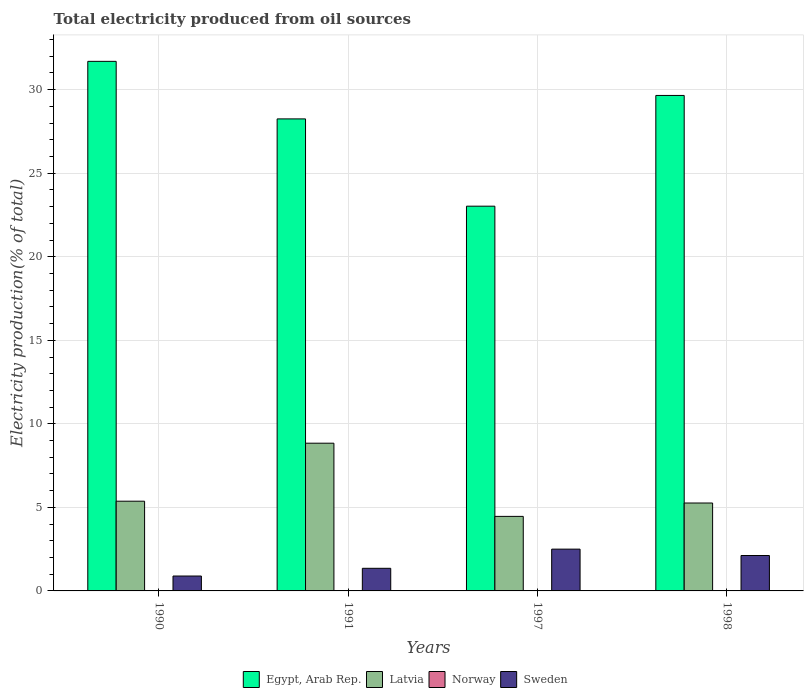How many groups of bars are there?
Keep it short and to the point. 4. How many bars are there on the 2nd tick from the left?
Your answer should be very brief. 4. What is the label of the 4th group of bars from the left?
Your response must be concise. 1998. What is the total electricity produced in Latvia in 1991?
Your answer should be compact. 8.84. Across all years, what is the maximum total electricity produced in Sweden?
Your answer should be very brief. 2.5. Across all years, what is the minimum total electricity produced in Norway?
Your answer should be compact. 0. In which year was the total electricity produced in Sweden maximum?
Offer a very short reply. 1997. In which year was the total electricity produced in Norway minimum?
Offer a very short reply. 1990. What is the total total electricity produced in Egypt, Arab Rep. in the graph?
Offer a very short reply. 112.63. What is the difference between the total electricity produced in Latvia in 1991 and that in 1998?
Provide a short and direct response. 3.58. What is the difference between the total electricity produced in Latvia in 1998 and the total electricity produced in Norway in 1991?
Give a very brief answer. 5.26. What is the average total electricity produced in Latvia per year?
Offer a terse response. 5.98. In the year 1997, what is the difference between the total electricity produced in Egypt, Arab Rep. and total electricity produced in Norway?
Provide a short and direct response. 23.02. In how many years, is the total electricity produced in Egypt, Arab Rep. greater than 30 %?
Your response must be concise. 1. What is the ratio of the total electricity produced in Latvia in 1997 to that in 1998?
Your response must be concise. 0.85. Is the total electricity produced in Latvia in 1990 less than that in 1998?
Offer a terse response. No. Is the difference between the total electricity produced in Egypt, Arab Rep. in 1990 and 1997 greater than the difference between the total electricity produced in Norway in 1990 and 1997?
Give a very brief answer. Yes. What is the difference between the highest and the second highest total electricity produced in Norway?
Your answer should be compact. 0. What is the difference between the highest and the lowest total electricity produced in Norway?
Provide a short and direct response. 0. In how many years, is the total electricity produced in Latvia greater than the average total electricity produced in Latvia taken over all years?
Ensure brevity in your answer.  1. Is the sum of the total electricity produced in Latvia in 1991 and 1997 greater than the maximum total electricity produced in Sweden across all years?
Offer a very short reply. Yes. What does the 4th bar from the right in 1997 represents?
Ensure brevity in your answer.  Egypt, Arab Rep. How many years are there in the graph?
Make the answer very short. 4. Does the graph contain any zero values?
Keep it short and to the point. No. Where does the legend appear in the graph?
Offer a very short reply. Bottom center. How are the legend labels stacked?
Your answer should be compact. Horizontal. What is the title of the graph?
Give a very brief answer. Total electricity produced from oil sources. What is the label or title of the X-axis?
Provide a succinct answer. Years. What is the Electricity production(% of total) in Egypt, Arab Rep. in 1990?
Give a very brief answer. 31.69. What is the Electricity production(% of total) of Latvia in 1990?
Your response must be concise. 5.37. What is the Electricity production(% of total) in Norway in 1990?
Your answer should be compact. 0. What is the Electricity production(% of total) in Sweden in 1990?
Offer a very short reply. 0.89. What is the Electricity production(% of total) of Egypt, Arab Rep. in 1991?
Provide a short and direct response. 28.25. What is the Electricity production(% of total) in Latvia in 1991?
Your response must be concise. 8.84. What is the Electricity production(% of total) of Norway in 1991?
Give a very brief answer. 0.01. What is the Electricity production(% of total) in Sweden in 1991?
Give a very brief answer. 1.35. What is the Electricity production(% of total) of Egypt, Arab Rep. in 1997?
Ensure brevity in your answer.  23.03. What is the Electricity production(% of total) in Latvia in 1997?
Your answer should be very brief. 4.46. What is the Electricity production(% of total) in Norway in 1997?
Offer a very short reply. 0.01. What is the Electricity production(% of total) in Sweden in 1997?
Give a very brief answer. 2.5. What is the Electricity production(% of total) of Egypt, Arab Rep. in 1998?
Provide a succinct answer. 29.65. What is the Electricity production(% of total) in Latvia in 1998?
Offer a very short reply. 5.26. What is the Electricity production(% of total) in Norway in 1998?
Ensure brevity in your answer.  0.01. What is the Electricity production(% of total) of Sweden in 1998?
Your response must be concise. 2.12. Across all years, what is the maximum Electricity production(% of total) of Egypt, Arab Rep.?
Ensure brevity in your answer.  31.69. Across all years, what is the maximum Electricity production(% of total) of Latvia?
Offer a very short reply. 8.84. Across all years, what is the maximum Electricity production(% of total) in Norway?
Offer a very short reply. 0.01. Across all years, what is the maximum Electricity production(% of total) in Sweden?
Keep it short and to the point. 2.5. Across all years, what is the minimum Electricity production(% of total) in Egypt, Arab Rep.?
Provide a succinct answer. 23.03. Across all years, what is the minimum Electricity production(% of total) in Latvia?
Offer a terse response. 4.46. Across all years, what is the minimum Electricity production(% of total) in Norway?
Keep it short and to the point. 0. Across all years, what is the minimum Electricity production(% of total) in Sweden?
Offer a very short reply. 0.89. What is the total Electricity production(% of total) in Egypt, Arab Rep. in the graph?
Keep it short and to the point. 112.63. What is the total Electricity production(% of total) in Latvia in the graph?
Your response must be concise. 23.93. What is the total Electricity production(% of total) of Norway in the graph?
Offer a very short reply. 0.02. What is the total Electricity production(% of total) of Sweden in the graph?
Offer a very short reply. 6.87. What is the difference between the Electricity production(% of total) in Egypt, Arab Rep. in 1990 and that in 1991?
Offer a very short reply. 3.44. What is the difference between the Electricity production(% of total) in Latvia in 1990 and that in 1991?
Your answer should be very brief. -3.47. What is the difference between the Electricity production(% of total) in Norway in 1990 and that in 1991?
Provide a short and direct response. -0. What is the difference between the Electricity production(% of total) in Sweden in 1990 and that in 1991?
Offer a terse response. -0.46. What is the difference between the Electricity production(% of total) in Egypt, Arab Rep. in 1990 and that in 1997?
Make the answer very short. 8.67. What is the difference between the Electricity production(% of total) of Latvia in 1990 and that in 1997?
Your response must be concise. 0.91. What is the difference between the Electricity production(% of total) of Norway in 1990 and that in 1997?
Give a very brief answer. -0. What is the difference between the Electricity production(% of total) of Sweden in 1990 and that in 1997?
Ensure brevity in your answer.  -1.61. What is the difference between the Electricity production(% of total) in Egypt, Arab Rep. in 1990 and that in 1998?
Your answer should be very brief. 2.04. What is the difference between the Electricity production(% of total) in Latvia in 1990 and that in 1998?
Give a very brief answer. 0.11. What is the difference between the Electricity production(% of total) in Norway in 1990 and that in 1998?
Give a very brief answer. -0. What is the difference between the Electricity production(% of total) in Sweden in 1990 and that in 1998?
Provide a short and direct response. -1.23. What is the difference between the Electricity production(% of total) in Egypt, Arab Rep. in 1991 and that in 1997?
Offer a very short reply. 5.22. What is the difference between the Electricity production(% of total) in Latvia in 1991 and that in 1997?
Give a very brief answer. 4.38. What is the difference between the Electricity production(% of total) in Norway in 1991 and that in 1997?
Your response must be concise. -0. What is the difference between the Electricity production(% of total) of Sweden in 1991 and that in 1997?
Provide a short and direct response. -1.15. What is the difference between the Electricity production(% of total) of Egypt, Arab Rep. in 1991 and that in 1998?
Offer a terse response. -1.4. What is the difference between the Electricity production(% of total) in Latvia in 1991 and that in 1998?
Ensure brevity in your answer.  3.58. What is the difference between the Electricity production(% of total) in Norway in 1991 and that in 1998?
Your answer should be very brief. 0. What is the difference between the Electricity production(% of total) of Sweden in 1991 and that in 1998?
Offer a terse response. -0.77. What is the difference between the Electricity production(% of total) in Egypt, Arab Rep. in 1997 and that in 1998?
Keep it short and to the point. -6.63. What is the difference between the Electricity production(% of total) in Latvia in 1997 and that in 1998?
Your answer should be compact. -0.8. What is the difference between the Electricity production(% of total) in Norway in 1997 and that in 1998?
Keep it short and to the point. 0. What is the difference between the Electricity production(% of total) in Sweden in 1997 and that in 1998?
Offer a very short reply. 0.38. What is the difference between the Electricity production(% of total) of Egypt, Arab Rep. in 1990 and the Electricity production(% of total) of Latvia in 1991?
Your answer should be very brief. 22.85. What is the difference between the Electricity production(% of total) of Egypt, Arab Rep. in 1990 and the Electricity production(% of total) of Norway in 1991?
Make the answer very short. 31.69. What is the difference between the Electricity production(% of total) of Egypt, Arab Rep. in 1990 and the Electricity production(% of total) of Sweden in 1991?
Offer a terse response. 30.34. What is the difference between the Electricity production(% of total) of Latvia in 1990 and the Electricity production(% of total) of Norway in 1991?
Offer a terse response. 5.36. What is the difference between the Electricity production(% of total) of Latvia in 1990 and the Electricity production(% of total) of Sweden in 1991?
Keep it short and to the point. 4.02. What is the difference between the Electricity production(% of total) in Norway in 1990 and the Electricity production(% of total) in Sweden in 1991?
Make the answer very short. -1.35. What is the difference between the Electricity production(% of total) in Egypt, Arab Rep. in 1990 and the Electricity production(% of total) in Latvia in 1997?
Give a very brief answer. 27.23. What is the difference between the Electricity production(% of total) in Egypt, Arab Rep. in 1990 and the Electricity production(% of total) in Norway in 1997?
Offer a terse response. 31.69. What is the difference between the Electricity production(% of total) in Egypt, Arab Rep. in 1990 and the Electricity production(% of total) in Sweden in 1997?
Offer a terse response. 29.19. What is the difference between the Electricity production(% of total) in Latvia in 1990 and the Electricity production(% of total) in Norway in 1997?
Give a very brief answer. 5.36. What is the difference between the Electricity production(% of total) of Latvia in 1990 and the Electricity production(% of total) of Sweden in 1997?
Your answer should be very brief. 2.87. What is the difference between the Electricity production(% of total) in Norway in 1990 and the Electricity production(% of total) in Sweden in 1997?
Provide a short and direct response. -2.5. What is the difference between the Electricity production(% of total) in Egypt, Arab Rep. in 1990 and the Electricity production(% of total) in Latvia in 1998?
Your response must be concise. 26.43. What is the difference between the Electricity production(% of total) of Egypt, Arab Rep. in 1990 and the Electricity production(% of total) of Norway in 1998?
Provide a short and direct response. 31.69. What is the difference between the Electricity production(% of total) in Egypt, Arab Rep. in 1990 and the Electricity production(% of total) in Sweden in 1998?
Give a very brief answer. 29.58. What is the difference between the Electricity production(% of total) in Latvia in 1990 and the Electricity production(% of total) in Norway in 1998?
Your response must be concise. 5.36. What is the difference between the Electricity production(% of total) in Latvia in 1990 and the Electricity production(% of total) in Sweden in 1998?
Offer a very short reply. 3.25. What is the difference between the Electricity production(% of total) in Norway in 1990 and the Electricity production(% of total) in Sweden in 1998?
Offer a terse response. -2.11. What is the difference between the Electricity production(% of total) of Egypt, Arab Rep. in 1991 and the Electricity production(% of total) of Latvia in 1997?
Your answer should be compact. 23.79. What is the difference between the Electricity production(% of total) in Egypt, Arab Rep. in 1991 and the Electricity production(% of total) in Norway in 1997?
Make the answer very short. 28.24. What is the difference between the Electricity production(% of total) of Egypt, Arab Rep. in 1991 and the Electricity production(% of total) of Sweden in 1997?
Your answer should be very brief. 25.75. What is the difference between the Electricity production(% of total) of Latvia in 1991 and the Electricity production(% of total) of Norway in 1997?
Make the answer very short. 8.83. What is the difference between the Electricity production(% of total) of Latvia in 1991 and the Electricity production(% of total) of Sweden in 1997?
Give a very brief answer. 6.34. What is the difference between the Electricity production(% of total) of Norway in 1991 and the Electricity production(% of total) of Sweden in 1997?
Offer a terse response. -2.49. What is the difference between the Electricity production(% of total) of Egypt, Arab Rep. in 1991 and the Electricity production(% of total) of Latvia in 1998?
Your answer should be very brief. 22.99. What is the difference between the Electricity production(% of total) of Egypt, Arab Rep. in 1991 and the Electricity production(% of total) of Norway in 1998?
Make the answer very short. 28.24. What is the difference between the Electricity production(% of total) of Egypt, Arab Rep. in 1991 and the Electricity production(% of total) of Sweden in 1998?
Offer a very short reply. 26.13. What is the difference between the Electricity production(% of total) of Latvia in 1991 and the Electricity production(% of total) of Norway in 1998?
Provide a short and direct response. 8.84. What is the difference between the Electricity production(% of total) of Latvia in 1991 and the Electricity production(% of total) of Sweden in 1998?
Give a very brief answer. 6.72. What is the difference between the Electricity production(% of total) in Norway in 1991 and the Electricity production(% of total) in Sweden in 1998?
Provide a short and direct response. -2.11. What is the difference between the Electricity production(% of total) in Egypt, Arab Rep. in 1997 and the Electricity production(% of total) in Latvia in 1998?
Your answer should be compact. 17.77. What is the difference between the Electricity production(% of total) in Egypt, Arab Rep. in 1997 and the Electricity production(% of total) in Norway in 1998?
Your answer should be compact. 23.02. What is the difference between the Electricity production(% of total) of Egypt, Arab Rep. in 1997 and the Electricity production(% of total) of Sweden in 1998?
Your response must be concise. 20.91. What is the difference between the Electricity production(% of total) in Latvia in 1997 and the Electricity production(% of total) in Norway in 1998?
Ensure brevity in your answer.  4.45. What is the difference between the Electricity production(% of total) in Latvia in 1997 and the Electricity production(% of total) in Sweden in 1998?
Make the answer very short. 2.34. What is the difference between the Electricity production(% of total) of Norway in 1997 and the Electricity production(% of total) of Sweden in 1998?
Ensure brevity in your answer.  -2.11. What is the average Electricity production(% of total) of Egypt, Arab Rep. per year?
Your answer should be very brief. 28.16. What is the average Electricity production(% of total) in Latvia per year?
Your response must be concise. 5.98. What is the average Electricity production(% of total) of Norway per year?
Make the answer very short. 0.01. What is the average Electricity production(% of total) of Sweden per year?
Provide a succinct answer. 1.72. In the year 1990, what is the difference between the Electricity production(% of total) in Egypt, Arab Rep. and Electricity production(% of total) in Latvia?
Provide a succinct answer. 26.32. In the year 1990, what is the difference between the Electricity production(% of total) in Egypt, Arab Rep. and Electricity production(% of total) in Norway?
Your answer should be very brief. 31.69. In the year 1990, what is the difference between the Electricity production(% of total) of Egypt, Arab Rep. and Electricity production(% of total) of Sweden?
Your response must be concise. 30.8. In the year 1990, what is the difference between the Electricity production(% of total) of Latvia and Electricity production(% of total) of Norway?
Provide a short and direct response. 5.37. In the year 1990, what is the difference between the Electricity production(% of total) of Latvia and Electricity production(% of total) of Sweden?
Provide a short and direct response. 4.48. In the year 1990, what is the difference between the Electricity production(% of total) of Norway and Electricity production(% of total) of Sweden?
Offer a very short reply. -0.89. In the year 1991, what is the difference between the Electricity production(% of total) of Egypt, Arab Rep. and Electricity production(% of total) of Latvia?
Offer a very short reply. 19.41. In the year 1991, what is the difference between the Electricity production(% of total) of Egypt, Arab Rep. and Electricity production(% of total) of Norway?
Your answer should be very brief. 28.24. In the year 1991, what is the difference between the Electricity production(% of total) in Egypt, Arab Rep. and Electricity production(% of total) in Sweden?
Provide a short and direct response. 26.9. In the year 1991, what is the difference between the Electricity production(% of total) in Latvia and Electricity production(% of total) in Norway?
Make the answer very short. 8.83. In the year 1991, what is the difference between the Electricity production(% of total) in Latvia and Electricity production(% of total) in Sweden?
Keep it short and to the point. 7.49. In the year 1991, what is the difference between the Electricity production(% of total) in Norway and Electricity production(% of total) in Sweden?
Keep it short and to the point. -1.35. In the year 1997, what is the difference between the Electricity production(% of total) of Egypt, Arab Rep. and Electricity production(% of total) of Latvia?
Make the answer very short. 18.57. In the year 1997, what is the difference between the Electricity production(% of total) in Egypt, Arab Rep. and Electricity production(% of total) in Norway?
Your answer should be very brief. 23.02. In the year 1997, what is the difference between the Electricity production(% of total) in Egypt, Arab Rep. and Electricity production(% of total) in Sweden?
Offer a terse response. 20.53. In the year 1997, what is the difference between the Electricity production(% of total) in Latvia and Electricity production(% of total) in Norway?
Keep it short and to the point. 4.45. In the year 1997, what is the difference between the Electricity production(% of total) of Latvia and Electricity production(% of total) of Sweden?
Ensure brevity in your answer.  1.96. In the year 1997, what is the difference between the Electricity production(% of total) of Norway and Electricity production(% of total) of Sweden?
Provide a short and direct response. -2.49. In the year 1998, what is the difference between the Electricity production(% of total) of Egypt, Arab Rep. and Electricity production(% of total) of Latvia?
Give a very brief answer. 24.39. In the year 1998, what is the difference between the Electricity production(% of total) of Egypt, Arab Rep. and Electricity production(% of total) of Norway?
Ensure brevity in your answer.  29.65. In the year 1998, what is the difference between the Electricity production(% of total) in Egypt, Arab Rep. and Electricity production(% of total) in Sweden?
Give a very brief answer. 27.53. In the year 1998, what is the difference between the Electricity production(% of total) of Latvia and Electricity production(% of total) of Norway?
Your answer should be compact. 5.26. In the year 1998, what is the difference between the Electricity production(% of total) of Latvia and Electricity production(% of total) of Sweden?
Provide a succinct answer. 3.14. In the year 1998, what is the difference between the Electricity production(% of total) in Norway and Electricity production(% of total) in Sweden?
Provide a succinct answer. -2.11. What is the ratio of the Electricity production(% of total) in Egypt, Arab Rep. in 1990 to that in 1991?
Make the answer very short. 1.12. What is the ratio of the Electricity production(% of total) in Latvia in 1990 to that in 1991?
Provide a succinct answer. 0.61. What is the ratio of the Electricity production(% of total) in Norway in 1990 to that in 1991?
Offer a very short reply. 0.78. What is the ratio of the Electricity production(% of total) in Sweden in 1990 to that in 1991?
Your answer should be compact. 0.66. What is the ratio of the Electricity production(% of total) of Egypt, Arab Rep. in 1990 to that in 1997?
Provide a short and direct response. 1.38. What is the ratio of the Electricity production(% of total) of Latvia in 1990 to that in 1997?
Offer a terse response. 1.2. What is the ratio of the Electricity production(% of total) of Norway in 1990 to that in 1997?
Your response must be concise. 0.68. What is the ratio of the Electricity production(% of total) in Sweden in 1990 to that in 1997?
Provide a succinct answer. 0.36. What is the ratio of the Electricity production(% of total) of Egypt, Arab Rep. in 1990 to that in 1998?
Your response must be concise. 1.07. What is the ratio of the Electricity production(% of total) of Latvia in 1990 to that in 1998?
Provide a short and direct response. 1.02. What is the ratio of the Electricity production(% of total) of Norway in 1990 to that in 1998?
Keep it short and to the point. 0.82. What is the ratio of the Electricity production(% of total) of Sweden in 1990 to that in 1998?
Keep it short and to the point. 0.42. What is the ratio of the Electricity production(% of total) in Egypt, Arab Rep. in 1991 to that in 1997?
Offer a terse response. 1.23. What is the ratio of the Electricity production(% of total) of Latvia in 1991 to that in 1997?
Your answer should be compact. 1.98. What is the ratio of the Electricity production(% of total) in Norway in 1991 to that in 1997?
Your answer should be compact. 0.87. What is the ratio of the Electricity production(% of total) in Sweden in 1991 to that in 1997?
Provide a succinct answer. 0.54. What is the ratio of the Electricity production(% of total) of Egypt, Arab Rep. in 1991 to that in 1998?
Make the answer very short. 0.95. What is the ratio of the Electricity production(% of total) in Latvia in 1991 to that in 1998?
Your response must be concise. 1.68. What is the ratio of the Electricity production(% of total) of Norway in 1991 to that in 1998?
Your answer should be compact. 1.05. What is the ratio of the Electricity production(% of total) of Sweden in 1991 to that in 1998?
Your response must be concise. 0.64. What is the ratio of the Electricity production(% of total) of Egypt, Arab Rep. in 1997 to that in 1998?
Your response must be concise. 0.78. What is the ratio of the Electricity production(% of total) in Latvia in 1997 to that in 1998?
Your answer should be compact. 0.85. What is the ratio of the Electricity production(% of total) in Norway in 1997 to that in 1998?
Offer a very short reply. 1.2. What is the ratio of the Electricity production(% of total) of Sweden in 1997 to that in 1998?
Offer a very short reply. 1.18. What is the difference between the highest and the second highest Electricity production(% of total) in Egypt, Arab Rep.?
Offer a terse response. 2.04. What is the difference between the highest and the second highest Electricity production(% of total) of Latvia?
Provide a succinct answer. 3.47. What is the difference between the highest and the second highest Electricity production(% of total) of Norway?
Your answer should be compact. 0. What is the difference between the highest and the second highest Electricity production(% of total) of Sweden?
Give a very brief answer. 0.38. What is the difference between the highest and the lowest Electricity production(% of total) in Egypt, Arab Rep.?
Offer a very short reply. 8.67. What is the difference between the highest and the lowest Electricity production(% of total) of Latvia?
Make the answer very short. 4.38. What is the difference between the highest and the lowest Electricity production(% of total) of Norway?
Give a very brief answer. 0. What is the difference between the highest and the lowest Electricity production(% of total) in Sweden?
Your answer should be very brief. 1.61. 